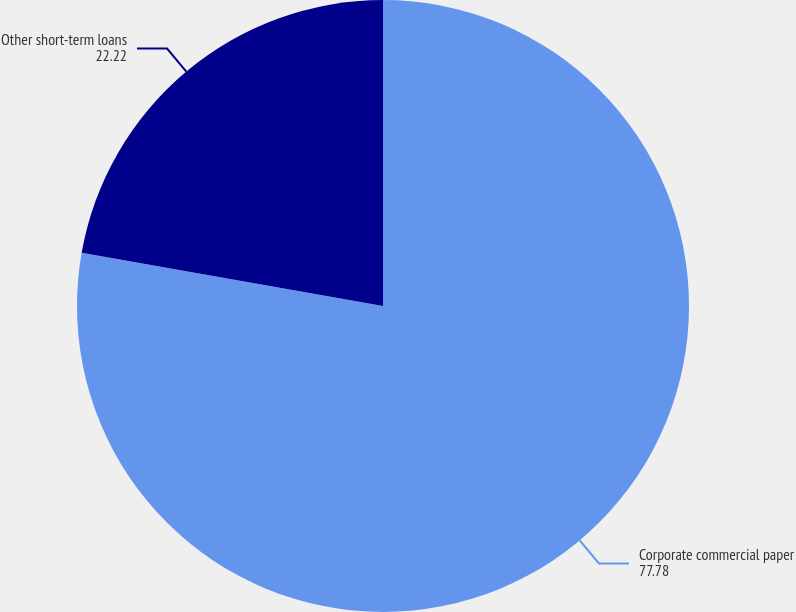<chart> <loc_0><loc_0><loc_500><loc_500><pie_chart><fcel>Corporate commercial paper<fcel>Other short-term loans<nl><fcel>77.78%<fcel>22.22%<nl></chart> 